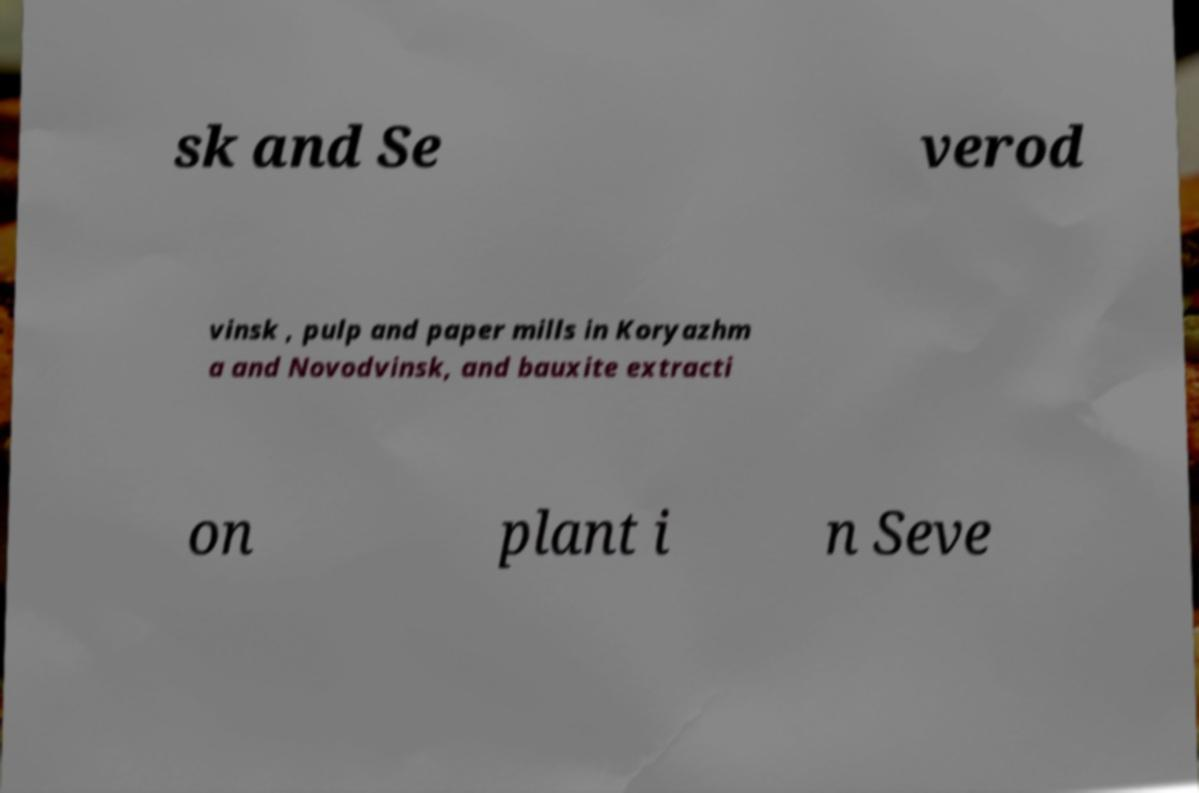Please identify and transcribe the text found in this image. sk and Se verod vinsk , pulp and paper mills in Koryazhm a and Novodvinsk, and bauxite extracti on plant i n Seve 